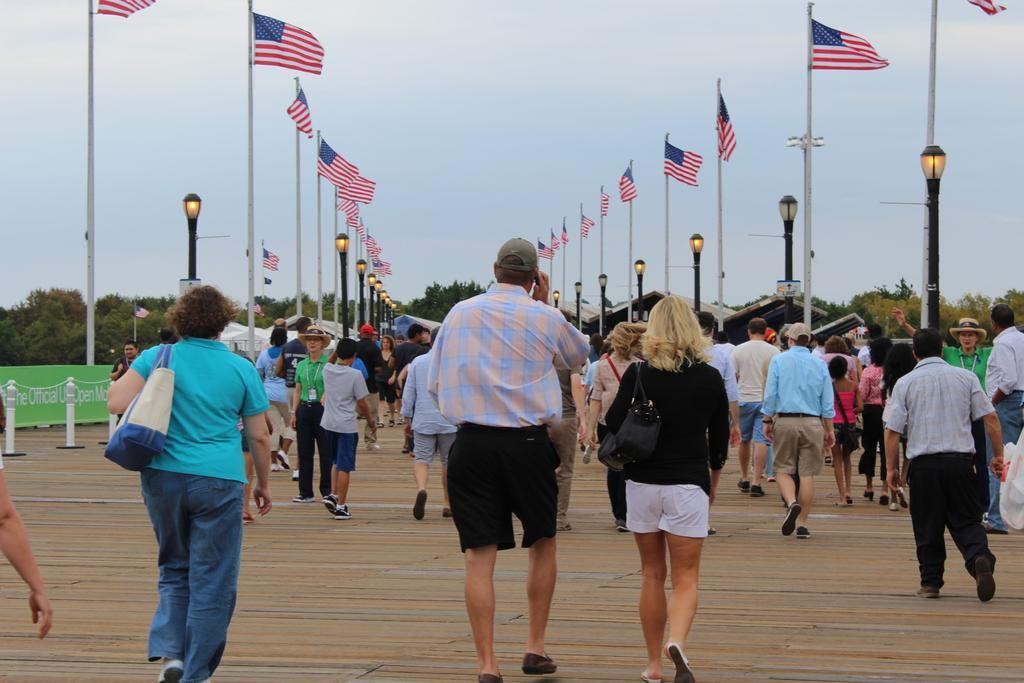How would you summarize this image in a sentence or two? In this image we can see a group of buildings. Behind the persons we can see sheds and poles with lights and flags. On the left side, we can see the poles and banners with text. In the background, we can see a group of trees. At the top we can see the sky. 